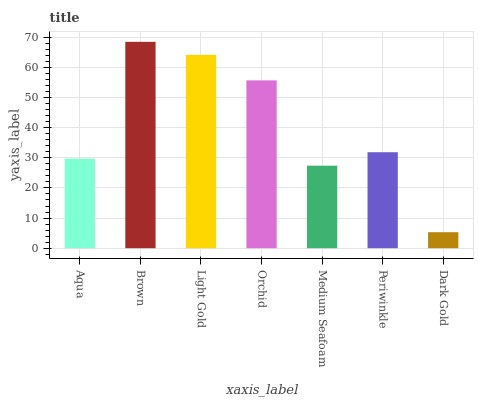Is Dark Gold the minimum?
Answer yes or no. Yes. Is Brown the maximum?
Answer yes or no. Yes. Is Light Gold the minimum?
Answer yes or no. No. Is Light Gold the maximum?
Answer yes or no. No. Is Brown greater than Light Gold?
Answer yes or no. Yes. Is Light Gold less than Brown?
Answer yes or no. Yes. Is Light Gold greater than Brown?
Answer yes or no. No. Is Brown less than Light Gold?
Answer yes or no. No. Is Periwinkle the high median?
Answer yes or no. Yes. Is Periwinkle the low median?
Answer yes or no. Yes. Is Brown the high median?
Answer yes or no. No. Is Brown the low median?
Answer yes or no. No. 